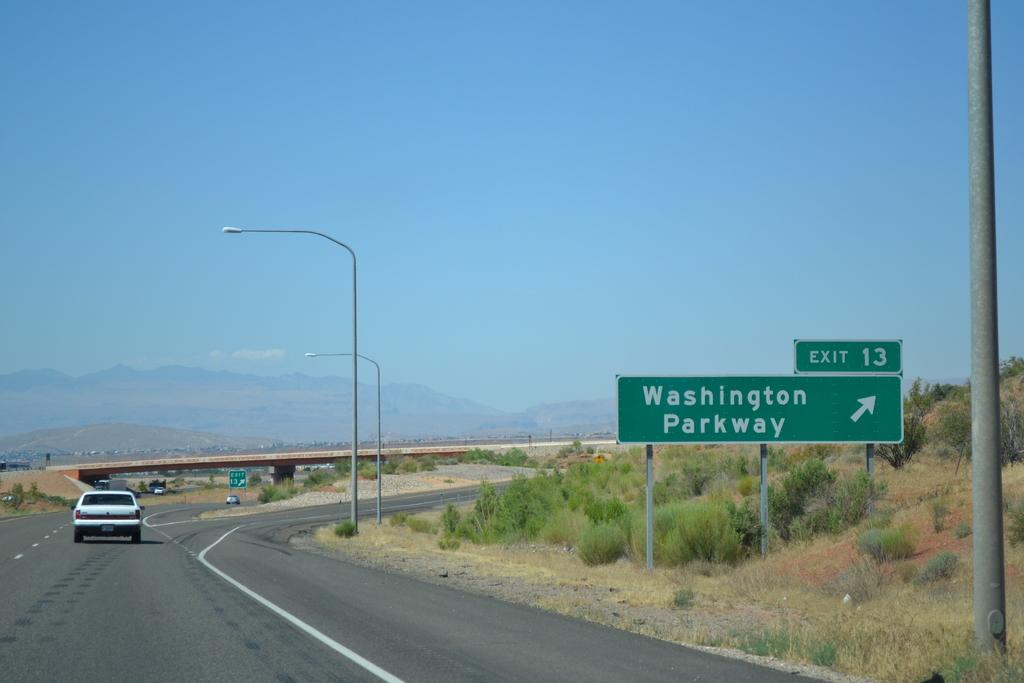Provide a one-sentence caption for the provided image. A highway with a sign that says exit 13. washington parkway. 